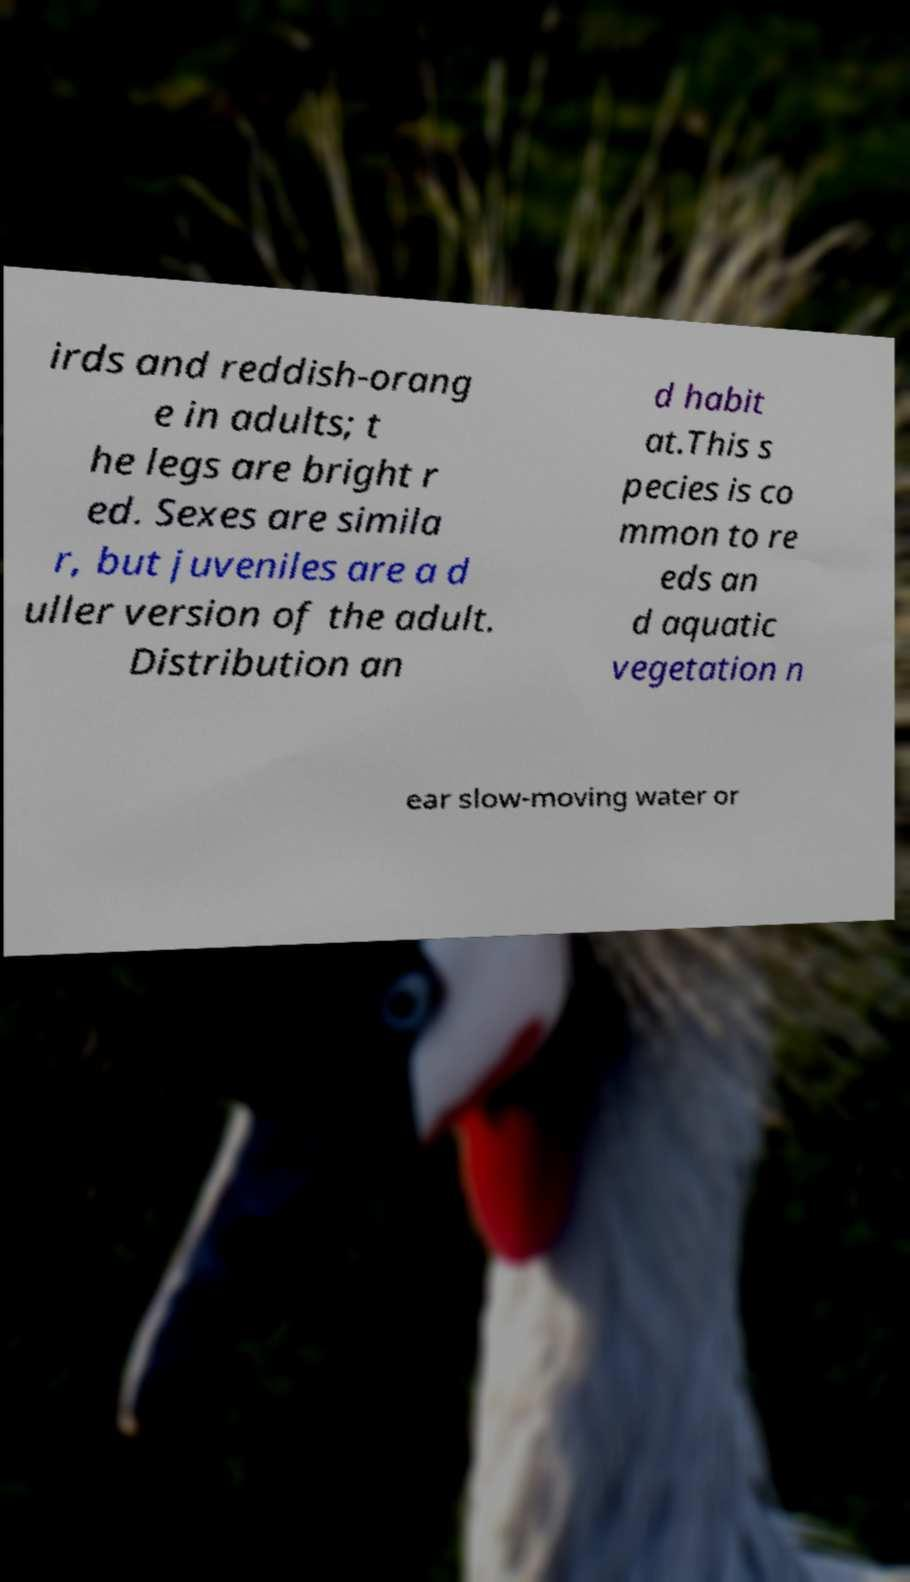Please read and relay the text visible in this image. What does it say? irds and reddish-orang e in adults; t he legs are bright r ed. Sexes are simila r, but juveniles are a d uller version of the adult. Distribution an d habit at.This s pecies is co mmon to re eds an d aquatic vegetation n ear slow-moving water or 